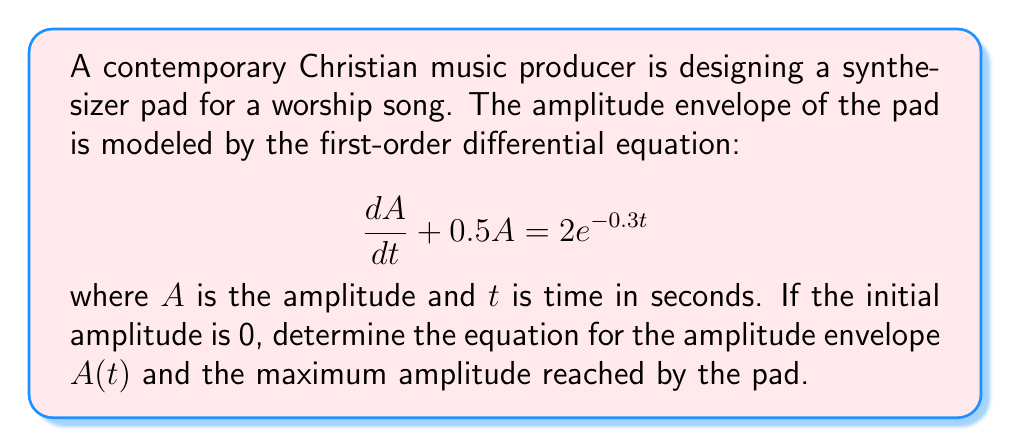Give your solution to this math problem. To solve this first-order linear differential equation, we'll use the integrating factor method:

1) The integrating factor is $\mu(t) = e^{\int 0.5 dt} = e^{0.5t}$

2) Multiply both sides of the equation by $\mu(t)$:

   $$e^{0.5t}\frac{dA}{dt} + 0.5e^{0.5t}A = 2e^{0.2t}$$

3) The left side is now the derivative of $e^{0.5t}A$:

   $$\frac{d}{dt}(e^{0.5t}A) = 2e^{0.2t}$$

4) Integrate both sides:

   $$e^{0.5t}A = \int 2e^{0.2t}dt = 10e^{0.2t} + C$$

5) Solve for $A$:

   $$A(t) = 10e^{-0.3t} + Ce^{-0.5t}$$

6) Use the initial condition $A(0) = 0$ to find $C$:

   $$0 = 10 + C \implies C = -10$$

7) The final solution is:

   $$A(t) = 10e^{-0.3t} - 10e^{-0.5t}$$

To find the maximum amplitude, differentiate $A(t)$ and set it to zero:

$$\frac{dA}{dt} = -3e^{-0.3t} + 5e^{-0.5t} = 0$$

Solving this equation:

$$e^{0.2t} = \frac{5}{3}$$

$$t = 5\ln(\frac{5}{3}) \approx 1.03\text{ seconds}$$

Substitute this time back into $A(t)$ to find the maximum amplitude.
Answer: The amplitude envelope is given by $A(t) = 10e^{-0.3t} - 10e^{-0.5t}$. The maximum amplitude of approximately 2.30 is reached at $t \approx 1.03$ seconds. 